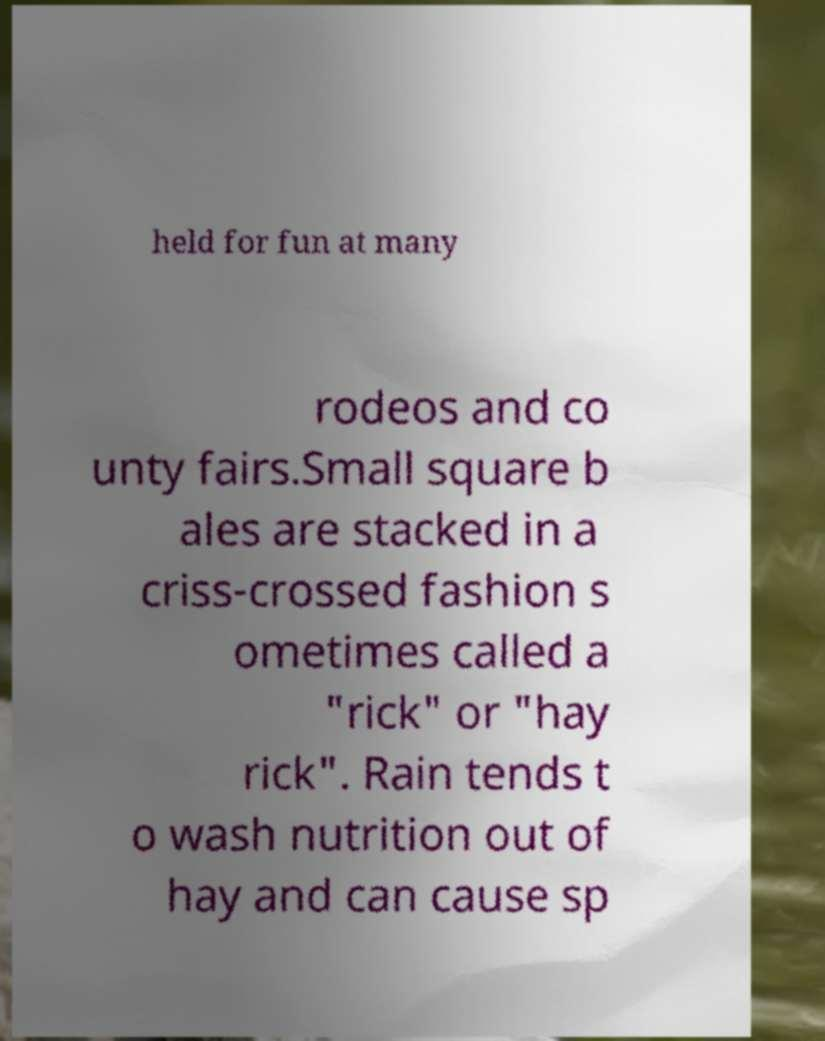There's text embedded in this image that I need extracted. Can you transcribe it verbatim? held for fun at many rodeos and co unty fairs.Small square b ales are stacked in a criss-crossed fashion s ometimes called a "rick" or "hay rick". Rain tends t o wash nutrition out of hay and can cause sp 